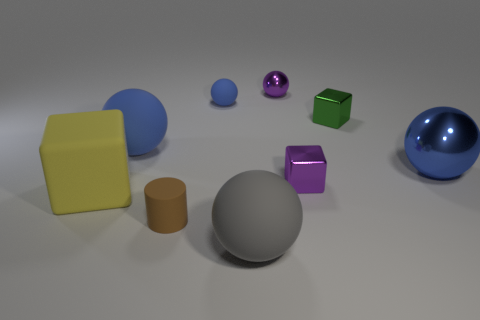Are there any other things that are the same color as the big cube?
Your answer should be very brief. No. How many balls are both to the right of the gray rubber ball and on the left side of the large blue shiny thing?
Give a very brief answer. 1. What is the large gray object made of?
Your response must be concise. Rubber. The green metallic thing that is the same size as the rubber cylinder is what shape?
Your answer should be very brief. Cube. Are the large blue sphere on the left side of the small purple cube and the cube to the left of the brown thing made of the same material?
Give a very brief answer. Yes. How many large red metal cylinders are there?
Offer a terse response. 0. How many other big metallic objects are the same shape as the green shiny object?
Provide a short and direct response. 0. Do the small blue matte thing and the large gray thing have the same shape?
Keep it short and to the point. Yes. What is the size of the matte cube?
Offer a terse response. Large. How many blue rubber objects have the same size as the brown rubber cylinder?
Give a very brief answer. 1. 